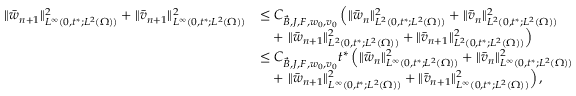<formula> <loc_0><loc_0><loc_500><loc_500>\begin{array} { r l } { \| \ B a r { w } _ { n + 1 } \| _ { L ^ { \infty } ( 0 , t ^ { * } ; L ^ { 2 } ( \Omega ) ) } ^ { 2 } + \| \ B a r { v } _ { n + 1 } \| _ { L ^ { \infty } ( 0 , t ^ { * } ; L ^ { 2 } ( \Omega ) ) } ^ { 2 } } & { \leq C _ { \ V e c { B } , J , F , w _ { 0 } , v _ { 0 } } \left ( \| \ B a r { w } _ { n } \| _ { L ^ { 2 } ( 0 , t ^ { * } ; L ^ { 2 } ( \Omega ) ) } ^ { 2 } + \| \ B a r { v } _ { n } \| _ { L ^ { 2 } ( 0 , t ^ { * } ; L ^ { 2 } ( \Omega ) ) } ^ { 2 } } \\ & { \quad + \| \ B a r { w } _ { n + 1 } \| _ { L ^ { 2 } ( 0 , t ^ { * } ; L ^ { 2 } ( \Omega ) ) } ^ { 2 } + \| \ B a r { v } _ { n + 1 } \| _ { L ^ { 2 } ( 0 , t ^ { * } ; L ^ { 2 } ( \Omega ) ) } ^ { 2 } \right ) } \\ & { \leq C _ { \ V e c { B } , J , F , w _ { 0 } , v _ { 0 } } t ^ { * } \left ( \| \ B a r { w } _ { n } \| _ { L ^ { \infty } ( 0 , t ^ { * } ; L ^ { 2 } ( \Omega ) ) } ^ { 2 } + \| \ B a r { v } _ { n } \| _ { L ^ { \infty } ( 0 , t ^ { * } ; L ^ { 2 } ( \Omega ) ) } ^ { 2 } } \\ & { \quad + \| \ B a r { w } _ { n + 1 } \| _ { L ^ { \infty } ( 0 , t ^ { * } ; L ^ { 2 } ( \Omega ) ) } ^ { 2 } + \| \ B a r { v } _ { n + 1 } \| _ { L ^ { \infty } ( 0 , t ^ { * } ; L ^ { 2 } ( \Omega ) ) } ^ { 2 } \right ) , } \end{array}</formula> 